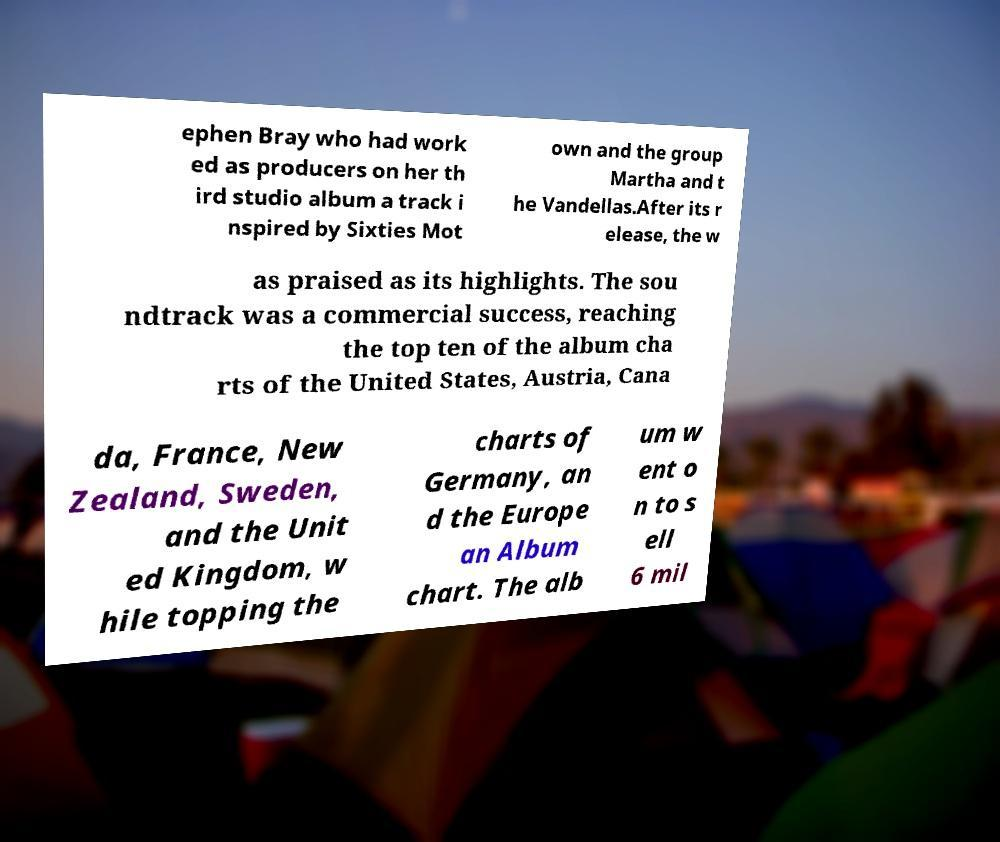There's text embedded in this image that I need extracted. Can you transcribe it verbatim? ephen Bray who had work ed as producers on her th ird studio album a track i nspired by Sixties Mot own and the group Martha and t he Vandellas.After its r elease, the w as praised as its highlights. The sou ndtrack was a commercial success, reaching the top ten of the album cha rts of the United States, Austria, Cana da, France, New Zealand, Sweden, and the Unit ed Kingdom, w hile topping the charts of Germany, an d the Europe an Album chart. The alb um w ent o n to s ell 6 mil 